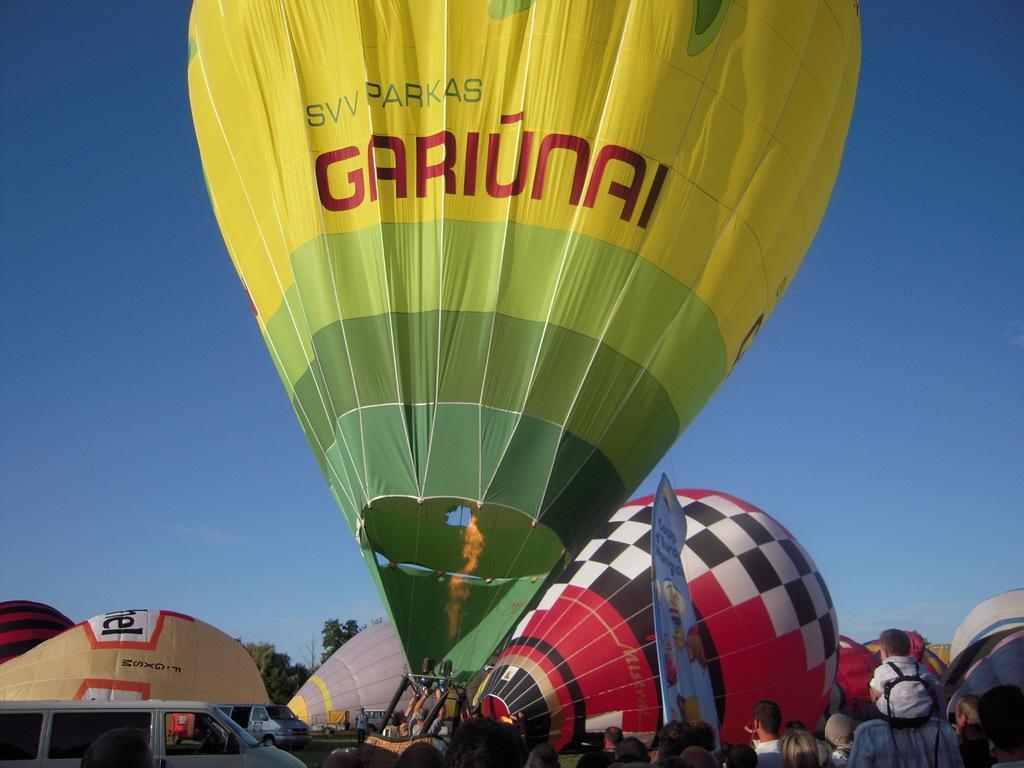Can you describe this image briefly? In this image we can see few parachutes, there are few people and a banner near the parachutes, there are vehicles on the ground and in the background there are trees and the sky. 